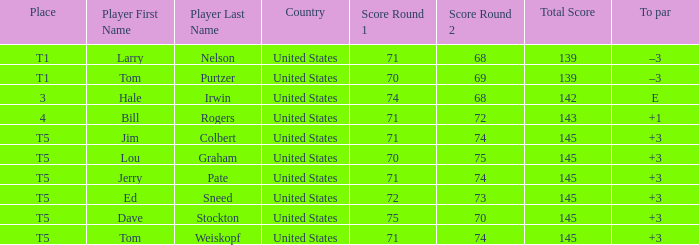What is the to par of player tom weiskopf, who has a 71-74=145 score? 3.0. Can you give me this table as a dict? {'header': ['Place', 'Player First Name', 'Player Last Name', 'Country', 'Score Round 1', 'Score Round 2', 'Total Score', 'To par'], 'rows': [['T1', 'Larry', 'Nelson', 'United States', '71', '68', '139', '–3'], ['T1', 'Tom', 'Purtzer', 'United States', '70', '69', '139', '–3'], ['3', 'Hale', 'Irwin', 'United States', '74', '68', '142', 'E'], ['4', 'Bill', 'Rogers', 'United States', '71', '72', '143', '+1'], ['T5', 'Jim', 'Colbert', 'United States', '71', '74', '145', '+3'], ['T5', 'Lou', 'Graham', 'United States', '70', '75', '145', '+3'], ['T5', 'Jerry', 'Pate', 'United States', '71', '74', '145', '+3'], ['T5', 'Ed', 'Sneed', 'United States', '72', '73', '145', '+3'], ['T5', 'Dave', 'Stockton', 'United States', '75', '70', '145', '+3'], ['T5', 'Tom', 'Weiskopf', 'United States', '71', '74', '145', '+3']]} 